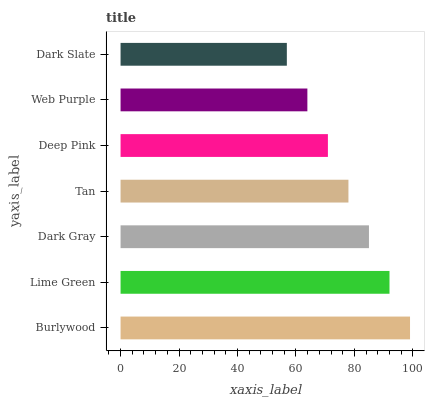Is Dark Slate the minimum?
Answer yes or no. Yes. Is Burlywood the maximum?
Answer yes or no. Yes. Is Lime Green the minimum?
Answer yes or no. No. Is Lime Green the maximum?
Answer yes or no. No. Is Burlywood greater than Lime Green?
Answer yes or no. Yes. Is Lime Green less than Burlywood?
Answer yes or no. Yes. Is Lime Green greater than Burlywood?
Answer yes or no. No. Is Burlywood less than Lime Green?
Answer yes or no. No. Is Tan the high median?
Answer yes or no. Yes. Is Tan the low median?
Answer yes or no. Yes. Is Burlywood the high median?
Answer yes or no. No. Is Deep Pink the low median?
Answer yes or no. No. 